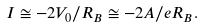Convert formula to latex. <formula><loc_0><loc_0><loc_500><loc_500>I \cong - 2 V _ { 0 } / R _ { B } \cong - 2 A / e R _ { B } .</formula> 